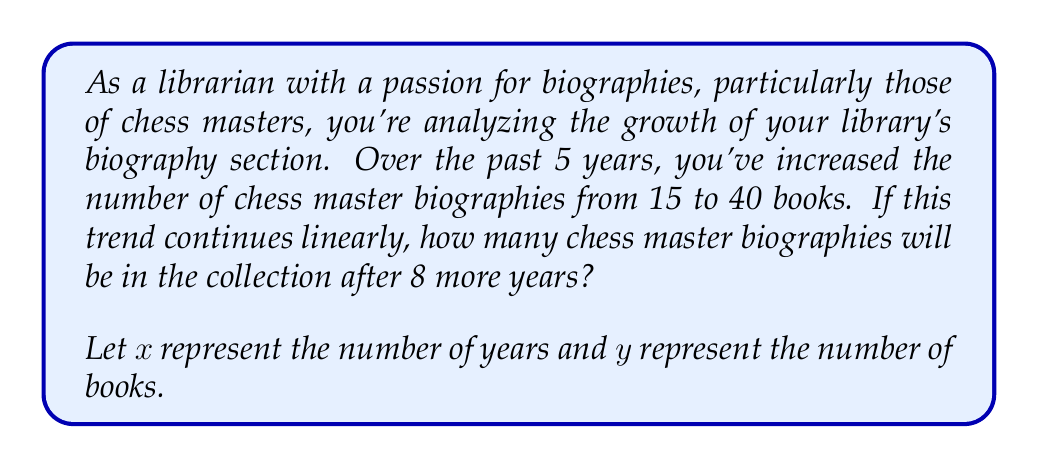What is the answer to this math problem? To solve this problem, we need to use the concept of linear growth and the point-slope form of a line.

1. First, let's calculate the rate of change (slope) of the book acquisitions:
   $$\text{Rate} = \frac{\text{Change in books}}{\text{Change in years}} = \frac{40 - 15}{5} = 5 \text{ books/year}$$

2. We can use the point-slope form of a line: $y - y_1 = m(x - x_1)$
   Where $(x_1, y_1)$ is a known point (in this case, (5, 40)), and $m$ is the slope (5 books/year).

3. Substituting these values:
   $y - 40 = 5(x - 5)$

4. We want to find $y$ when $x = 13$ (5 years that have passed + 8 more years):
   $y - 40 = 5(13 - 5)$
   $y - 40 = 5(8)$
   $y - 40 = 40$
   $y = 80$

Therefore, after 8 more years, there will be 80 chess master biographies in the collection.
Answer: 80 chess master biographies 